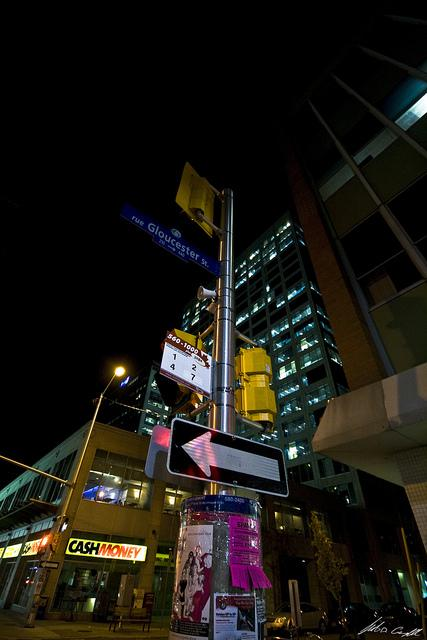What does the white arrow sign usually mean? Please explain your reasoning. one way. The white arrow means one way. 